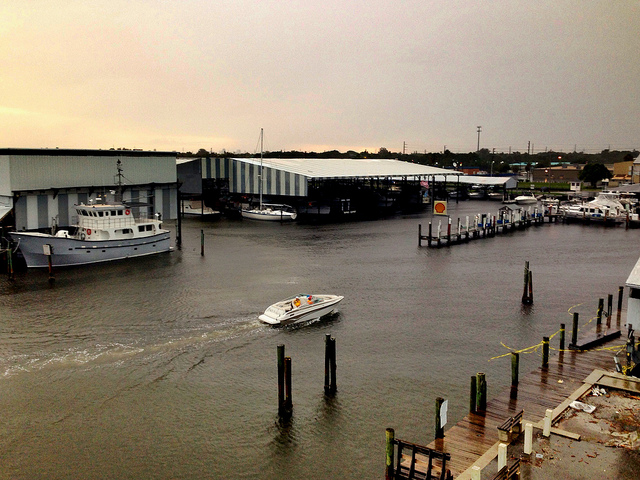<image>What does the blue building say? I am not sure what the blue building says. It could be 'shell', 'marina', or 'dock'. What does the blue building say? I don't know what does the blue building say. It seems like it says 'shell', 'marina', or 'dock'. 